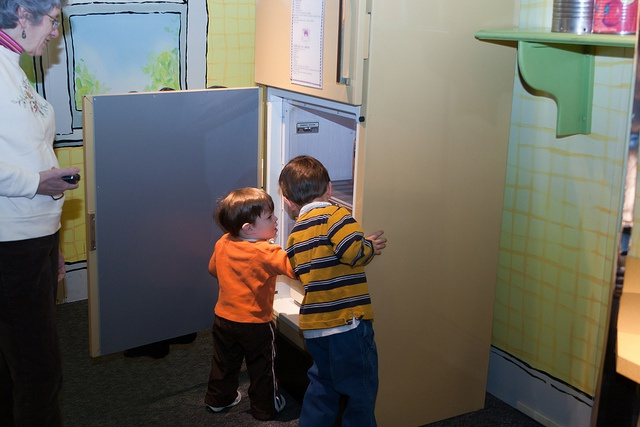Describe the objects in this image and their specific colors. I can see refrigerator in darkblue, gray, and black tones, people in darkblue, black, darkgray, and lightgray tones, people in darkblue, black, maroon, and olive tones, people in darkblue, black, red, maroon, and brown tones, and cell phone in darkblue, black, and gray tones in this image. 